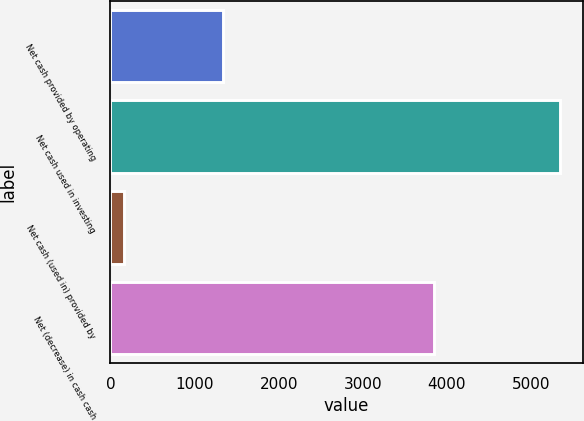Convert chart to OTSL. <chart><loc_0><loc_0><loc_500><loc_500><bar_chart><fcel>Net cash provided by operating<fcel>Net cash used in investing<fcel>Net cash (used in) provided by<fcel>Net (decrease) in cash cash<nl><fcel>1335<fcel>5349<fcel>164<fcel>3850<nl></chart> 